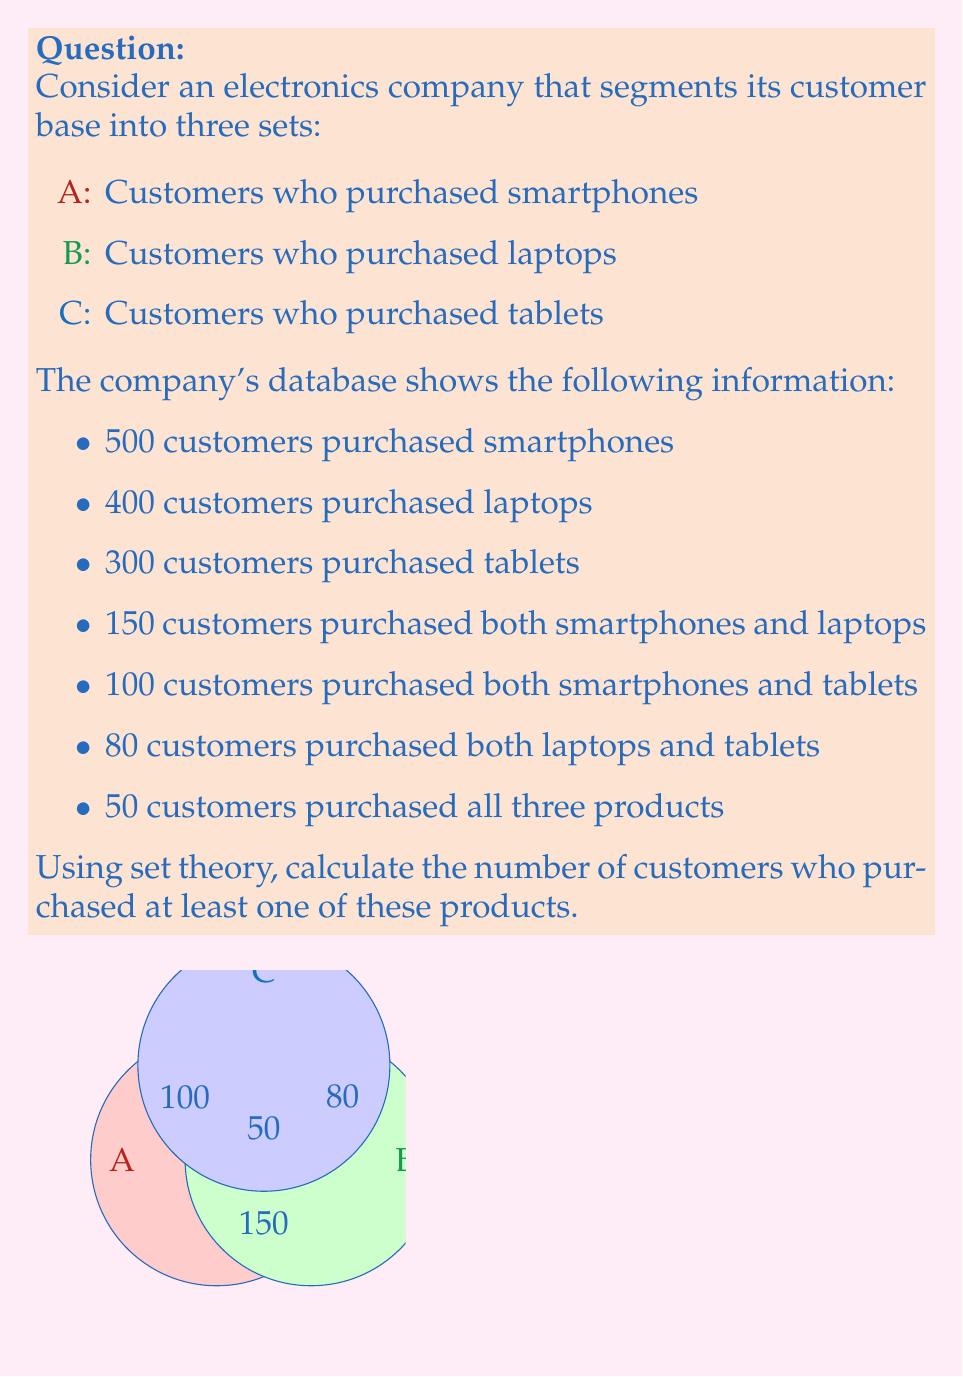What is the answer to this math problem? Let's approach this step-by-step using set theory:

1) First, we need to understand what the question is asking. We're looking for $|A \cup B \cup C|$, which is the total number of unique customers who purchased at least one of the products.

2) We can use the Inclusion-Exclusion Principle:

   $|A \cup B \cup C| = |A| + |B| + |C| - |A \cap B| - |A \cap C| - |B \cap C| + |A \cap B \cap C|$

3) We know:
   $|A| = 500$
   $|B| = 400$
   $|C| = 300$
   $|A \cap B| = 150$
   $|A \cap C| = 100$
   $|B \cap C| = 80$
   $|A \cap B \cap C| = 50$

4) Now, let's substitute these values into our equation:

   $|A \cup B \cup C| = 500 + 400 + 300 - 150 - 100 - 80 + 50$

5) Simplify:
   $|A \cup B \cup C| = 1200 - 330 + 50 = 920$

Therefore, 920 customers purchased at least one of these products.
Answer: 920 customers 